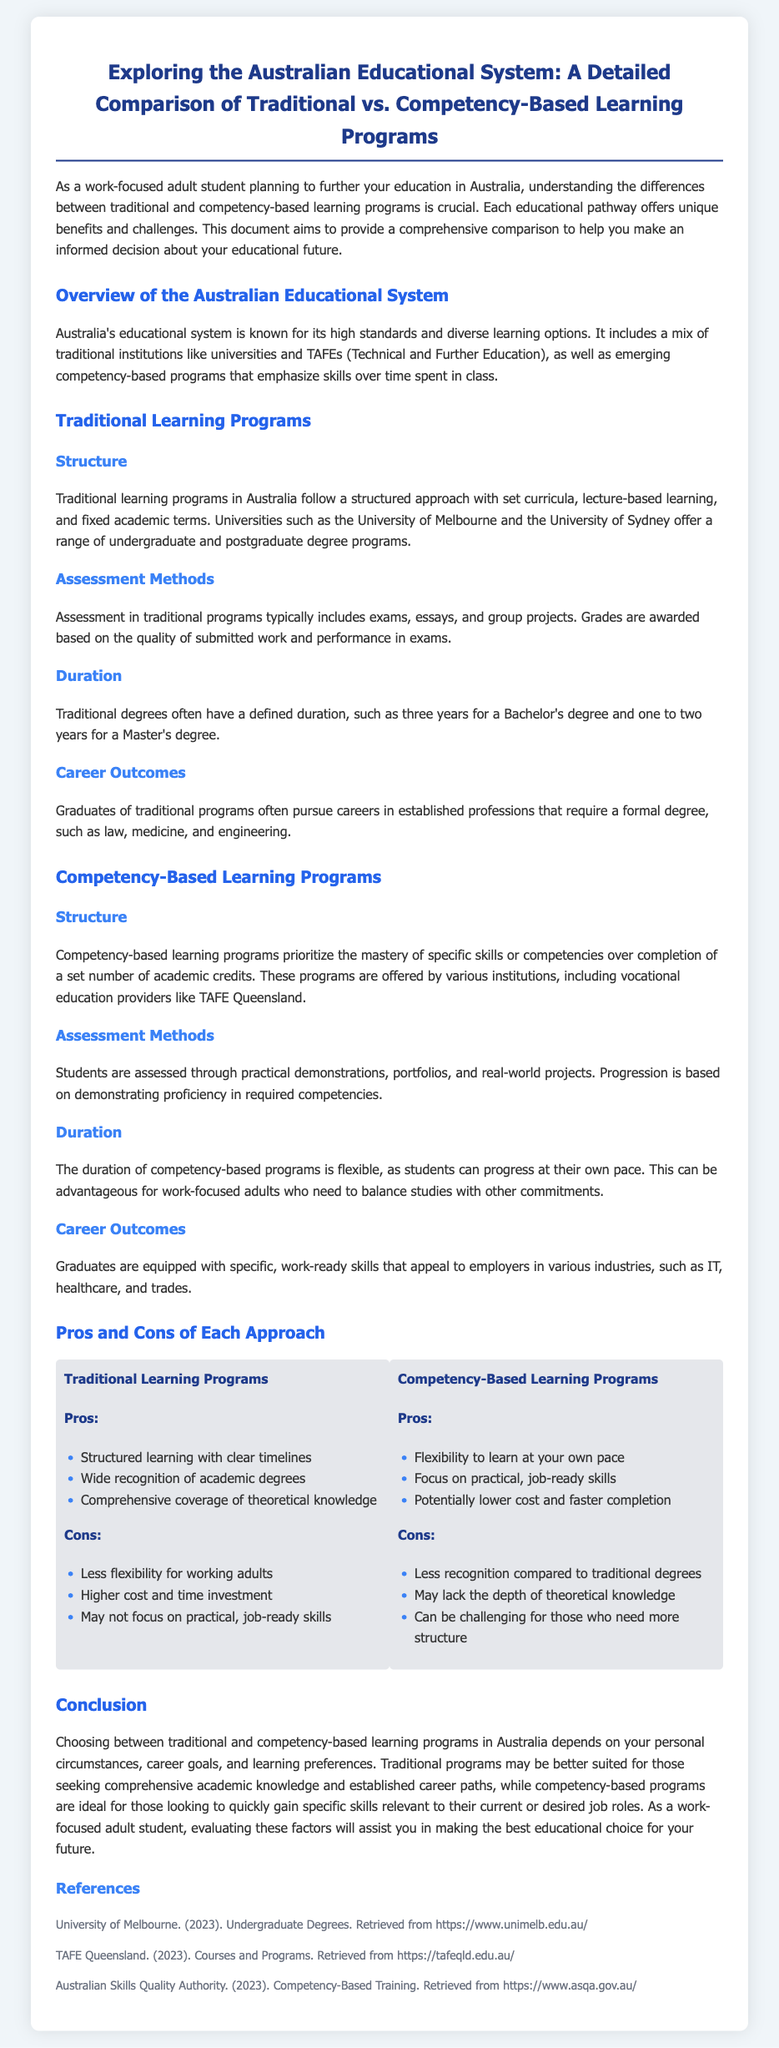what is the main focus of the document? The document compares traditional and competency-based learning programs in Australia to aid a work-focused adult in making an educational decision.
Answer: comparison of traditional and competency-based learning programs how many years does a Bachelor's degree typically take in traditional programs? Traditional degrees often have a defined duration, such as three years for a Bachelor's degree.
Answer: three years what type of assessment methods are used in traditional learning programs? Assessment in traditional programs typically includes exams, essays, and group projects.
Answer: exams, essays, and group projects which institution offers competency-based learning programs mentioned in the document? Competency-based learning programs are offered by various institutions, including vocational education providers like TAFE Queensland.
Answer: TAFE Queensland what is a key advantage of competency-based learning programs? Pros include flexibility to learn at your own pace and a focus on practical, job-ready skills.
Answer: flexibility to learn at your own pace what are traditional programs better suited for according to the conclusion? Traditional programs may be better suited for those seeking comprehensive academic knowledge and established career paths.
Answer: comprehensive academic knowledge and established career paths what is a potential disadvantage of competency-based learning programs? A downside is that they may lack the depth of theoretical knowledge compared to traditional programs.
Answer: lack the depth of theoretical knowledge which career fields benefit from graduates of competency-based programs? Graduates are equipped with specific, work-ready skills that appeal to employers in various industries, such as IT, healthcare, and trades.
Answer: IT, healthcare, and trades how does the document describe the duration of competency-based programs? The duration of competency-based programs is flexible, as students can progress at their own pace.
Answer: flexible 